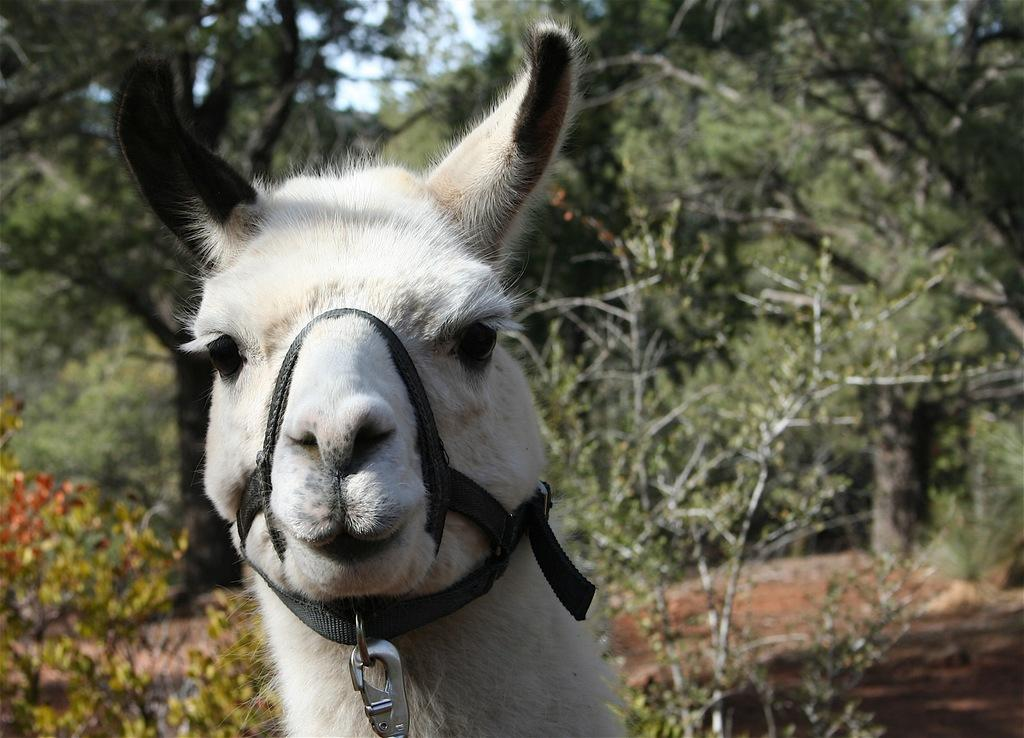What type of animal can be seen at the bottom of the image? There is an animal present at the bottom of the image. What can be seen in the distance behind the animal? There are trees visible in the background of the image. What type of paste is being used by the monkey in the image? There is no monkey present in the image, and therefore no paste can be observed. 